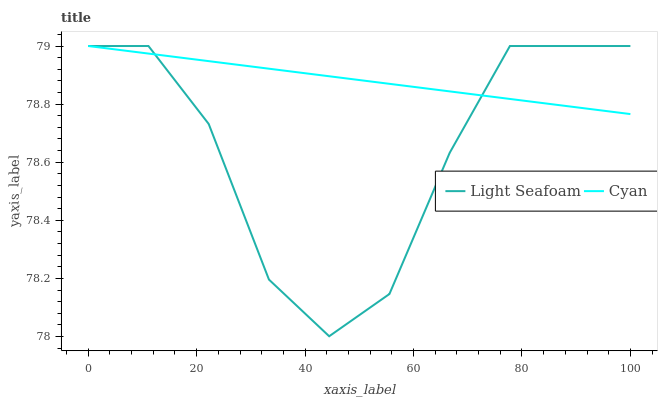Does Light Seafoam have the minimum area under the curve?
Answer yes or no. Yes. Does Cyan have the maximum area under the curve?
Answer yes or no. Yes. Does Light Seafoam have the maximum area under the curve?
Answer yes or no. No. Is Cyan the smoothest?
Answer yes or no. Yes. Is Light Seafoam the roughest?
Answer yes or no. Yes. Is Light Seafoam the smoothest?
Answer yes or no. No. 